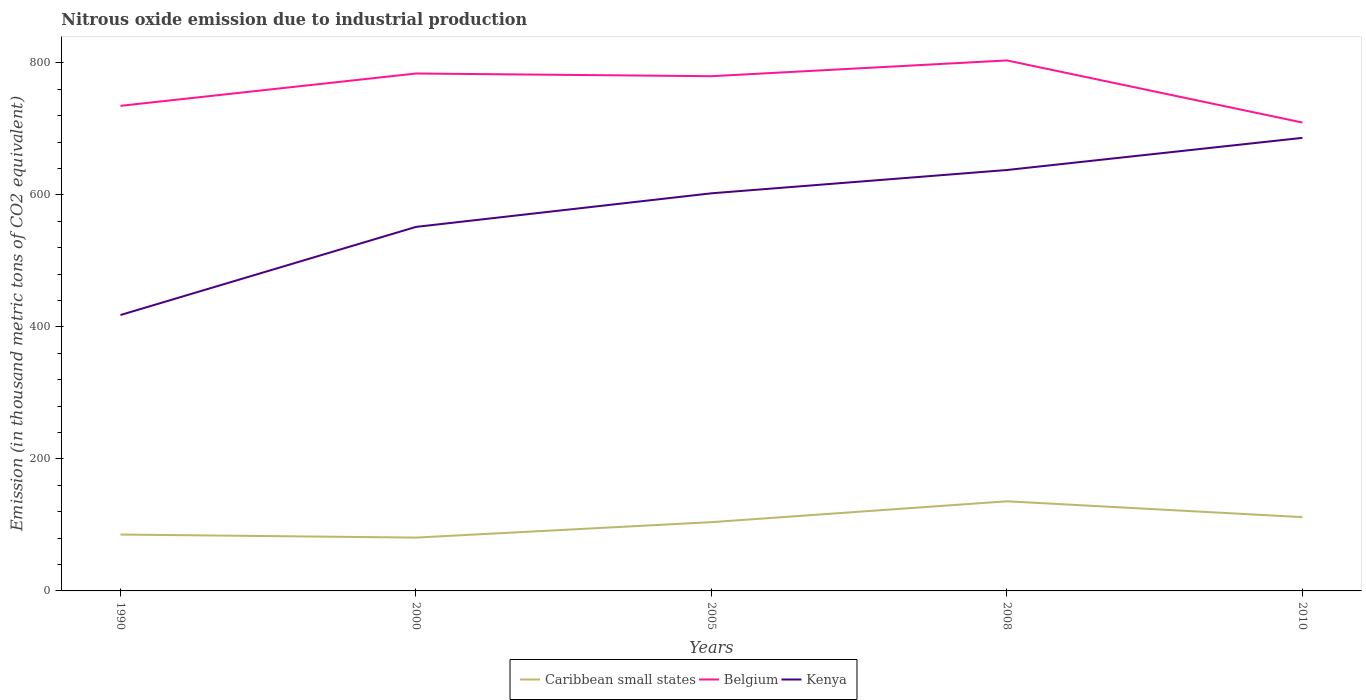Is the number of lines equal to the number of legend labels?
Offer a terse response. Yes. Across all years, what is the maximum amount of nitrous oxide emitted in Belgium?
Your answer should be very brief. 709.6. What is the total amount of nitrous oxide emitted in Caribbean small states in the graph?
Your answer should be very brief. -7.6. What is the difference between the highest and the second highest amount of nitrous oxide emitted in Caribbean small states?
Your answer should be compact. 55. Is the amount of nitrous oxide emitted in Kenya strictly greater than the amount of nitrous oxide emitted in Caribbean small states over the years?
Your answer should be very brief. No. How many lines are there?
Offer a very short reply. 3. How many years are there in the graph?
Your answer should be compact. 5. What is the difference between two consecutive major ticks on the Y-axis?
Keep it short and to the point. 200. Are the values on the major ticks of Y-axis written in scientific E-notation?
Your response must be concise. No. What is the title of the graph?
Provide a succinct answer. Nitrous oxide emission due to industrial production. What is the label or title of the X-axis?
Your answer should be compact. Years. What is the label or title of the Y-axis?
Your answer should be very brief. Emission (in thousand metric tons of CO2 equivalent). What is the Emission (in thousand metric tons of CO2 equivalent) in Caribbean small states in 1990?
Your answer should be compact. 85.4. What is the Emission (in thousand metric tons of CO2 equivalent) of Belgium in 1990?
Offer a terse response. 734.9. What is the Emission (in thousand metric tons of CO2 equivalent) of Kenya in 1990?
Provide a succinct answer. 418. What is the Emission (in thousand metric tons of CO2 equivalent) of Caribbean small states in 2000?
Give a very brief answer. 80.8. What is the Emission (in thousand metric tons of CO2 equivalent) of Belgium in 2000?
Provide a short and direct response. 783.9. What is the Emission (in thousand metric tons of CO2 equivalent) in Kenya in 2000?
Your response must be concise. 551.5. What is the Emission (in thousand metric tons of CO2 equivalent) of Caribbean small states in 2005?
Your answer should be very brief. 104.2. What is the Emission (in thousand metric tons of CO2 equivalent) in Belgium in 2005?
Ensure brevity in your answer.  779.8. What is the Emission (in thousand metric tons of CO2 equivalent) of Kenya in 2005?
Offer a terse response. 602.4. What is the Emission (in thousand metric tons of CO2 equivalent) in Caribbean small states in 2008?
Provide a short and direct response. 135.8. What is the Emission (in thousand metric tons of CO2 equivalent) in Belgium in 2008?
Your answer should be very brief. 803.7. What is the Emission (in thousand metric tons of CO2 equivalent) in Kenya in 2008?
Keep it short and to the point. 637.7. What is the Emission (in thousand metric tons of CO2 equivalent) of Caribbean small states in 2010?
Offer a terse response. 111.8. What is the Emission (in thousand metric tons of CO2 equivalent) in Belgium in 2010?
Your answer should be very brief. 709.6. What is the Emission (in thousand metric tons of CO2 equivalent) in Kenya in 2010?
Offer a terse response. 686.4. Across all years, what is the maximum Emission (in thousand metric tons of CO2 equivalent) in Caribbean small states?
Give a very brief answer. 135.8. Across all years, what is the maximum Emission (in thousand metric tons of CO2 equivalent) of Belgium?
Make the answer very short. 803.7. Across all years, what is the maximum Emission (in thousand metric tons of CO2 equivalent) in Kenya?
Give a very brief answer. 686.4. Across all years, what is the minimum Emission (in thousand metric tons of CO2 equivalent) of Caribbean small states?
Give a very brief answer. 80.8. Across all years, what is the minimum Emission (in thousand metric tons of CO2 equivalent) in Belgium?
Make the answer very short. 709.6. Across all years, what is the minimum Emission (in thousand metric tons of CO2 equivalent) of Kenya?
Your response must be concise. 418. What is the total Emission (in thousand metric tons of CO2 equivalent) in Caribbean small states in the graph?
Your answer should be compact. 518. What is the total Emission (in thousand metric tons of CO2 equivalent) of Belgium in the graph?
Provide a short and direct response. 3811.9. What is the total Emission (in thousand metric tons of CO2 equivalent) of Kenya in the graph?
Make the answer very short. 2896. What is the difference between the Emission (in thousand metric tons of CO2 equivalent) in Caribbean small states in 1990 and that in 2000?
Provide a short and direct response. 4.6. What is the difference between the Emission (in thousand metric tons of CO2 equivalent) of Belgium in 1990 and that in 2000?
Give a very brief answer. -49. What is the difference between the Emission (in thousand metric tons of CO2 equivalent) in Kenya in 1990 and that in 2000?
Provide a short and direct response. -133.5. What is the difference between the Emission (in thousand metric tons of CO2 equivalent) in Caribbean small states in 1990 and that in 2005?
Give a very brief answer. -18.8. What is the difference between the Emission (in thousand metric tons of CO2 equivalent) of Belgium in 1990 and that in 2005?
Your answer should be very brief. -44.9. What is the difference between the Emission (in thousand metric tons of CO2 equivalent) in Kenya in 1990 and that in 2005?
Keep it short and to the point. -184.4. What is the difference between the Emission (in thousand metric tons of CO2 equivalent) in Caribbean small states in 1990 and that in 2008?
Your answer should be very brief. -50.4. What is the difference between the Emission (in thousand metric tons of CO2 equivalent) in Belgium in 1990 and that in 2008?
Provide a succinct answer. -68.8. What is the difference between the Emission (in thousand metric tons of CO2 equivalent) in Kenya in 1990 and that in 2008?
Your answer should be very brief. -219.7. What is the difference between the Emission (in thousand metric tons of CO2 equivalent) of Caribbean small states in 1990 and that in 2010?
Ensure brevity in your answer.  -26.4. What is the difference between the Emission (in thousand metric tons of CO2 equivalent) of Belgium in 1990 and that in 2010?
Provide a short and direct response. 25.3. What is the difference between the Emission (in thousand metric tons of CO2 equivalent) in Kenya in 1990 and that in 2010?
Offer a terse response. -268.4. What is the difference between the Emission (in thousand metric tons of CO2 equivalent) of Caribbean small states in 2000 and that in 2005?
Provide a short and direct response. -23.4. What is the difference between the Emission (in thousand metric tons of CO2 equivalent) of Kenya in 2000 and that in 2005?
Provide a succinct answer. -50.9. What is the difference between the Emission (in thousand metric tons of CO2 equivalent) of Caribbean small states in 2000 and that in 2008?
Offer a very short reply. -55. What is the difference between the Emission (in thousand metric tons of CO2 equivalent) in Belgium in 2000 and that in 2008?
Your response must be concise. -19.8. What is the difference between the Emission (in thousand metric tons of CO2 equivalent) of Kenya in 2000 and that in 2008?
Make the answer very short. -86.2. What is the difference between the Emission (in thousand metric tons of CO2 equivalent) in Caribbean small states in 2000 and that in 2010?
Offer a terse response. -31. What is the difference between the Emission (in thousand metric tons of CO2 equivalent) of Belgium in 2000 and that in 2010?
Make the answer very short. 74.3. What is the difference between the Emission (in thousand metric tons of CO2 equivalent) in Kenya in 2000 and that in 2010?
Offer a terse response. -134.9. What is the difference between the Emission (in thousand metric tons of CO2 equivalent) of Caribbean small states in 2005 and that in 2008?
Make the answer very short. -31.6. What is the difference between the Emission (in thousand metric tons of CO2 equivalent) of Belgium in 2005 and that in 2008?
Your response must be concise. -23.9. What is the difference between the Emission (in thousand metric tons of CO2 equivalent) in Kenya in 2005 and that in 2008?
Your response must be concise. -35.3. What is the difference between the Emission (in thousand metric tons of CO2 equivalent) of Belgium in 2005 and that in 2010?
Ensure brevity in your answer.  70.2. What is the difference between the Emission (in thousand metric tons of CO2 equivalent) of Kenya in 2005 and that in 2010?
Your answer should be very brief. -84. What is the difference between the Emission (in thousand metric tons of CO2 equivalent) in Belgium in 2008 and that in 2010?
Ensure brevity in your answer.  94.1. What is the difference between the Emission (in thousand metric tons of CO2 equivalent) in Kenya in 2008 and that in 2010?
Your answer should be compact. -48.7. What is the difference between the Emission (in thousand metric tons of CO2 equivalent) in Caribbean small states in 1990 and the Emission (in thousand metric tons of CO2 equivalent) in Belgium in 2000?
Your answer should be compact. -698.5. What is the difference between the Emission (in thousand metric tons of CO2 equivalent) in Caribbean small states in 1990 and the Emission (in thousand metric tons of CO2 equivalent) in Kenya in 2000?
Offer a terse response. -466.1. What is the difference between the Emission (in thousand metric tons of CO2 equivalent) in Belgium in 1990 and the Emission (in thousand metric tons of CO2 equivalent) in Kenya in 2000?
Your answer should be compact. 183.4. What is the difference between the Emission (in thousand metric tons of CO2 equivalent) in Caribbean small states in 1990 and the Emission (in thousand metric tons of CO2 equivalent) in Belgium in 2005?
Make the answer very short. -694.4. What is the difference between the Emission (in thousand metric tons of CO2 equivalent) in Caribbean small states in 1990 and the Emission (in thousand metric tons of CO2 equivalent) in Kenya in 2005?
Give a very brief answer. -517. What is the difference between the Emission (in thousand metric tons of CO2 equivalent) of Belgium in 1990 and the Emission (in thousand metric tons of CO2 equivalent) of Kenya in 2005?
Your answer should be very brief. 132.5. What is the difference between the Emission (in thousand metric tons of CO2 equivalent) in Caribbean small states in 1990 and the Emission (in thousand metric tons of CO2 equivalent) in Belgium in 2008?
Keep it short and to the point. -718.3. What is the difference between the Emission (in thousand metric tons of CO2 equivalent) in Caribbean small states in 1990 and the Emission (in thousand metric tons of CO2 equivalent) in Kenya in 2008?
Make the answer very short. -552.3. What is the difference between the Emission (in thousand metric tons of CO2 equivalent) of Belgium in 1990 and the Emission (in thousand metric tons of CO2 equivalent) of Kenya in 2008?
Provide a short and direct response. 97.2. What is the difference between the Emission (in thousand metric tons of CO2 equivalent) in Caribbean small states in 1990 and the Emission (in thousand metric tons of CO2 equivalent) in Belgium in 2010?
Keep it short and to the point. -624.2. What is the difference between the Emission (in thousand metric tons of CO2 equivalent) in Caribbean small states in 1990 and the Emission (in thousand metric tons of CO2 equivalent) in Kenya in 2010?
Your response must be concise. -601. What is the difference between the Emission (in thousand metric tons of CO2 equivalent) in Belgium in 1990 and the Emission (in thousand metric tons of CO2 equivalent) in Kenya in 2010?
Offer a terse response. 48.5. What is the difference between the Emission (in thousand metric tons of CO2 equivalent) in Caribbean small states in 2000 and the Emission (in thousand metric tons of CO2 equivalent) in Belgium in 2005?
Your answer should be compact. -699. What is the difference between the Emission (in thousand metric tons of CO2 equivalent) in Caribbean small states in 2000 and the Emission (in thousand metric tons of CO2 equivalent) in Kenya in 2005?
Provide a short and direct response. -521.6. What is the difference between the Emission (in thousand metric tons of CO2 equivalent) in Belgium in 2000 and the Emission (in thousand metric tons of CO2 equivalent) in Kenya in 2005?
Your response must be concise. 181.5. What is the difference between the Emission (in thousand metric tons of CO2 equivalent) of Caribbean small states in 2000 and the Emission (in thousand metric tons of CO2 equivalent) of Belgium in 2008?
Make the answer very short. -722.9. What is the difference between the Emission (in thousand metric tons of CO2 equivalent) in Caribbean small states in 2000 and the Emission (in thousand metric tons of CO2 equivalent) in Kenya in 2008?
Offer a very short reply. -556.9. What is the difference between the Emission (in thousand metric tons of CO2 equivalent) of Belgium in 2000 and the Emission (in thousand metric tons of CO2 equivalent) of Kenya in 2008?
Offer a terse response. 146.2. What is the difference between the Emission (in thousand metric tons of CO2 equivalent) in Caribbean small states in 2000 and the Emission (in thousand metric tons of CO2 equivalent) in Belgium in 2010?
Give a very brief answer. -628.8. What is the difference between the Emission (in thousand metric tons of CO2 equivalent) in Caribbean small states in 2000 and the Emission (in thousand metric tons of CO2 equivalent) in Kenya in 2010?
Give a very brief answer. -605.6. What is the difference between the Emission (in thousand metric tons of CO2 equivalent) in Belgium in 2000 and the Emission (in thousand metric tons of CO2 equivalent) in Kenya in 2010?
Provide a short and direct response. 97.5. What is the difference between the Emission (in thousand metric tons of CO2 equivalent) of Caribbean small states in 2005 and the Emission (in thousand metric tons of CO2 equivalent) of Belgium in 2008?
Offer a very short reply. -699.5. What is the difference between the Emission (in thousand metric tons of CO2 equivalent) in Caribbean small states in 2005 and the Emission (in thousand metric tons of CO2 equivalent) in Kenya in 2008?
Keep it short and to the point. -533.5. What is the difference between the Emission (in thousand metric tons of CO2 equivalent) of Belgium in 2005 and the Emission (in thousand metric tons of CO2 equivalent) of Kenya in 2008?
Your answer should be very brief. 142.1. What is the difference between the Emission (in thousand metric tons of CO2 equivalent) in Caribbean small states in 2005 and the Emission (in thousand metric tons of CO2 equivalent) in Belgium in 2010?
Make the answer very short. -605.4. What is the difference between the Emission (in thousand metric tons of CO2 equivalent) in Caribbean small states in 2005 and the Emission (in thousand metric tons of CO2 equivalent) in Kenya in 2010?
Offer a very short reply. -582.2. What is the difference between the Emission (in thousand metric tons of CO2 equivalent) of Belgium in 2005 and the Emission (in thousand metric tons of CO2 equivalent) of Kenya in 2010?
Offer a terse response. 93.4. What is the difference between the Emission (in thousand metric tons of CO2 equivalent) of Caribbean small states in 2008 and the Emission (in thousand metric tons of CO2 equivalent) of Belgium in 2010?
Your answer should be compact. -573.8. What is the difference between the Emission (in thousand metric tons of CO2 equivalent) in Caribbean small states in 2008 and the Emission (in thousand metric tons of CO2 equivalent) in Kenya in 2010?
Give a very brief answer. -550.6. What is the difference between the Emission (in thousand metric tons of CO2 equivalent) of Belgium in 2008 and the Emission (in thousand metric tons of CO2 equivalent) of Kenya in 2010?
Ensure brevity in your answer.  117.3. What is the average Emission (in thousand metric tons of CO2 equivalent) of Caribbean small states per year?
Your response must be concise. 103.6. What is the average Emission (in thousand metric tons of CO2 equivalent) in Belgium per year?
Make the answer very short. 762.38. What is the average Emission (in thousand metric tons of CO2 equivalent) in Kenya per year?
Keep it short and to the point. 579.2. In the year 1990, what is the difference between the Emission (in thousand metric tons of CO2 equivalent) in Caribbean small states and Emission (in thousand metric tons of CO2 equivalent) in Belgium?
Offer a very short reply. -649.5. In the year 1990, what is the difference between the Emission (in thousand metric tons of CO2 equivalent) of Caribbean small states and Emission (in thousand metric tons of CO2 equivalent) of Kenya?
Give a very brief answer. -332.6. In the year 1990, what is the difference between the Emission (in thousand metric tons of CO2 equivalent) in Belgium and Emission (in thousand metric tons of CO2 equivalent) in Kenya?
Your answer should be very brief. 316.9. In the year 2000, what is the difference between the Emission (in thousand metric tons of CO2 equivalent) of Caribbean small states and Emission (in thousand metric tons of CO2 equivalent) of Belgium?
Make the answer very short. -703.1. In the year 2000, what is the difference between the Emission (in thousand metric tons of CO2 equivalent) of Caribbean small states and Emission (in thousand metric tons of CO2 equivalent) of Kenya?
Provide a succinct answer. -470.7. In the year 2000, what is the difference between the Emission (in thousand metric tons of CO2 equivalent) in Belgium and Emission (in thousand metric tons of CO2 equivalent) in Kenya?
Your response must be concise. 232.4. In the year 2005, what is the difference between the Emission (in thousand metric tons of CO2 equivalent) of Caribbean small states and Emission (in thousand metric tons of CO2 equivalent) of Belgium?
Provide a short and direct response. -675.6. In the year 2005, what is the difference between the Emission (in thousand metric tons of CO2 equivalent) in Caribbean small states and Emission (in thousand metric tons of CO2 equivalent) in Kenya?
Keep it short and to the point. -498.2. In the year 2005, what is the difference between the Emission (in thousand metric tons of CO2 equivalent) in Belgium and Emission (in thousand metric tons of CO2 equivalent) in Kenya?
Offer a very short reply. 177.4. In the year 2008, what is the difference between the Emission (in thousand metric tons of CO2 equivalent) of Caribbean small states and Emission (in thousand metric tons of CO2 equivalent) of Belgium?
Offer a terse response. -667.9. In the year 2008, what is the difference between the Emission (in thousand metric tons of CO2 equivalent) of Caribbean small states and Emission (in thousand metric tons of CO2 equivalent) of Kenya?
Offer a terse response. -501.9. In the year 2008, what is the difference between the Emission (in thousand metric tons of CO2 equivalent) of Belgium and Emission (in thousand metric tons of CO2 equivalent) of Kenya?
Offer a very short reply. 166. In the year 2010, what is the difference between the Emission (in thousand metric tons of CO2 equivalent) of Caribbean small states and Emission (in thousand metric tons of CO2 equivalent) of Belgium?
Provide a short and direct response. -597.8. In the year 2010, what is the difference between the Emission (in thousand metric tons of CO2 equivalent) of Caribbean small states and Emission (in thousand metric tons of CO2 equivalent) of Kenya?
Keep it short and to the point. -574.6. In the year 2010, what is the difference between the Emission (in thousand metric tons of CO2 equivalent) in Belgium and Emission (in thousand metric tons of CO2 equivalent) in Kenya?
Provide a succinct answer. 23.2. What is the ratio of the Emission (in thousand metric tons of CO2 equivalent) of Caribbean small states in 1990 to that in 2000?
Make the answer very short. 1.06. What is the ratio of the Emission (in thousand metric tons of CO2 equivalent) in Belgium in 1990 to that in 2000?
Keep it short and to the point. 0.94. What is the ratio of the Emission (in thousand metric tons of CO2 equivalent) in Kenya in 1990 to that in 2000?
Give a very brief answer. 0.76. What is the ratio of the Emission (in thousand metric tons of CO2 equivalent) in Caribbean small states in 1990 to that in 2005?
Ensure brevity in your answer.  0.82. What is the ratio of the Emission (in thousand metric tons of CO2 equivalent) of Belgium in 1990 to that in 2005?
Give a very brief answer. 0.94. What is the ratio of the Emission (in thousand metric tons of CO2 equivalent) of Kenya in 1990 to that in 2005?
Provide a short and direct response. 0.69. What is the ratio of the Emission (in thousand metric tons of CO2 equivalent) of Caribbean small states in 1990 to that in 2008?
Ensure brevity in your answer.  0.63. What is the ratio of the Emission (in thousand metric tons of CO2 equivalent) of Belgium in 1990 to that in 2008?
Give a very brief answer. 0.91. What is the ratio of the Emission (in thousand metric tons of CO2 equivalent) of Kenya in 1990 to that in 2008?
Give a very brief answer. 0.66. What is the ratio of the Emission (in thousand metric tons of CO2 equivalent) of Caribbean small states in 1990 to that in 2010?
Ensure brevity in your answer.  0.76. What is the ratio of the Emission (in thousand metric tons of CO2 equivalent) of Belgium in 1990 to that in 2010?
Your response must be concise. 1.04. What is the ratio of the Emission (in thousand metric tons of CO2 equivalent) in Kenya in 1990 to that in 2010?
Your answer should be compact. 0.61. What is the ratio of the Emission (in thousand metric tons of CO2 equivalent) of Caribbean small states in 2000 to that in 2005?
Your answer should be very brief. 0.78. What is the ratio of the Emission (in thousand metric tons of CO2 equivalent) in Kenya in 2000 to that in 2005?
Make the answer very short. 0.92. What is the ratio of the Emission (in thousand metric tons of CO2 equivalent) of Caribbean small states in 2000 to that in 2008?
Give a very brief answer. 0.59. What is the ratio of the Emission (in thousand metric tons of CO2 equivalent) in Belgium in 2000 to that in 2008?
Provide a succinct answer. 0.98. What is the ratio of the Emission (in thousand metric tons of CO2 equivalent) of Kenya in 2000 to that in 2008?
Ensure brevity in your answer.  0.86. What is the ratio of the Emission (in thousand metric tons of CO2 equivalent) of Caribbean small states in 2000 to that in 2010?
Offer a very short reply. 0.72. What is the ratio of the Emission (in thousand metric tons of CO2 equivalent) of Belgium in 2000 to that in 2010?
Your answer should be very brief. 1.1. What is the ratio of the Emission (in thousand metric tons of CO2 equivalent) in Kenya in 2000 to that in 2010?
Offer a very short reply. 0.8. What is the ratio of the Emission (in thousand metric tons of CO2 equivalent) of Caribbean small states in 2005 to that in 2008?
Give a very brief answer. 0.77. What is the ratio of the Emission (in thousand metric tons of CO2 equivalent) of Belgium in 2005 to that in 2008?
Your answer should be compact. 0.97. What is the ratio of the Emission (in thousand metric tons of CO2 equivalent) of Kenya in 2005 to that in 2008?
Your answer should be compact. 0.94. What is the ratio of the Emission (in thousand metric tons of CO2 equivalent) in Caribbean small states in 2005 to that in 2010?
Provide a succinct answer. 0.93. What is the ratio of the Emission (in thousand metric tons of CO2 equivalent) of Belgium in 2005 to that in 2010?
Give a very brief answer. 1.1. What is the ratio of the Emission (in thousand metric tons of CO2 equivalent) of Kenya in 2005 to that in 2010?
Provide a succinct answer. 0.88. What is the ratio of the Emission (in thousand metric tons of CO2 equivalent) of Caribbean small states in 2008 to that in 2010?
Provide a succinct answer. 1.21. What is the ratio of the Emission (in thousand metric tons of CO2 equivalent) of Belgium in 2008 to that in 2010?
Offer a very short reply. 1.13. What is the ratio of the Emission (in thousand metric tons of CO2 equivalent) in Kenya in 2008 to that in 2010?
Give a very brief answer. 0.93. What is the difference between the highest and the second highest Emission (in thousand metric tons of CO2 equivalent) in Belgium?
Offer a terse response. 19.8. What is the difference between the highest and the second highest Emission (in thousand metric tons of CO2 equivalent) of Kenya?
Your answer should be compact. 48.7. What is the difference between the highest and the lowest Emission (in thousand metric tons of CO2 equivalent) of Caribbean small states?
Your answer should be very brief. 55. What is the difference between the highest and the lowest Emission (in thousand metric tons of CO2 equivalent) in Belgium?
Offer a very short reply. 94.1. What is the difference between the highest and the lowest Emission (in thousand metric tons of CO2 equivalent) of Kenya?
Your answer should be very brief. 268.4. 